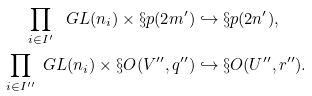<formula> <loc_0><loc_0><loc_500><loc_500>\prod _ { i \in I ^ { \prime } } \ G L ( n _ { i } ) \times \S p ( 2 m ^ { \prime } ) & \hookrightarrow \S p ( 2 n ^ { \prime } ) , \\ \prod _ { i \in I ^ { \prime \prime } } \ G L ( n _ { i } ) \times \S O ( V ^ { \prime \prime } , q ^ { \prime \prime } ) & \hookrightarrow \S O ( U ^ { \prime \prime } , r ^ { \prime \prime } ) .</formula> 